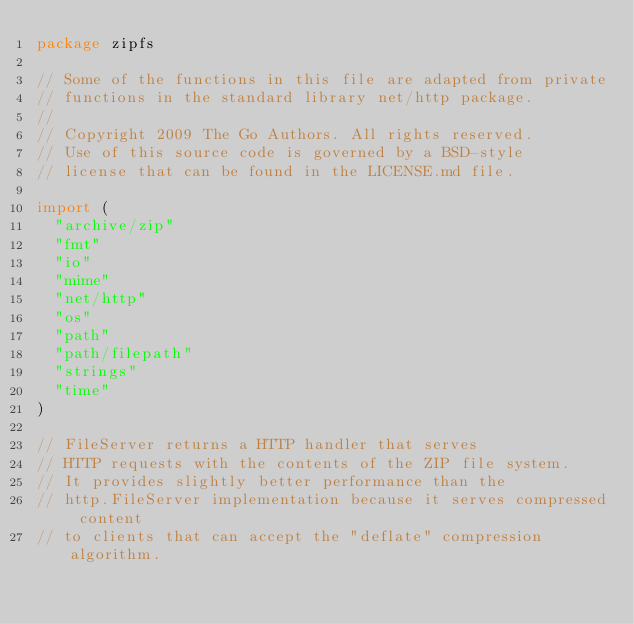<code> <loc_0><loc_0><loc_500><loc_500><_Go_>package zipfs

// Some of the functions in this file are adapted from private
// functions in the standard library net/http package.
//
// Copyright 2009 The Go Authors. All rights reserved.
// Use of this source code is governed by a BSD-style
// license that can be found in the LICENSE.md file.

import (
	"archive/zip"
	"fmt"
	"io"
	"mime"
	"net/http"
	"os"
	"path"
	"path/filepath"
	"strings"
	"time"
)

// FileServer returns a HTTP handler that serves
// HTTP requests with the contents of the ZIP file system.
// It provides slightly better performance than the
// http.FileServer implementation because it serves compressed content
// to clients that can accept the "deflate" compression algorithm.</code> 